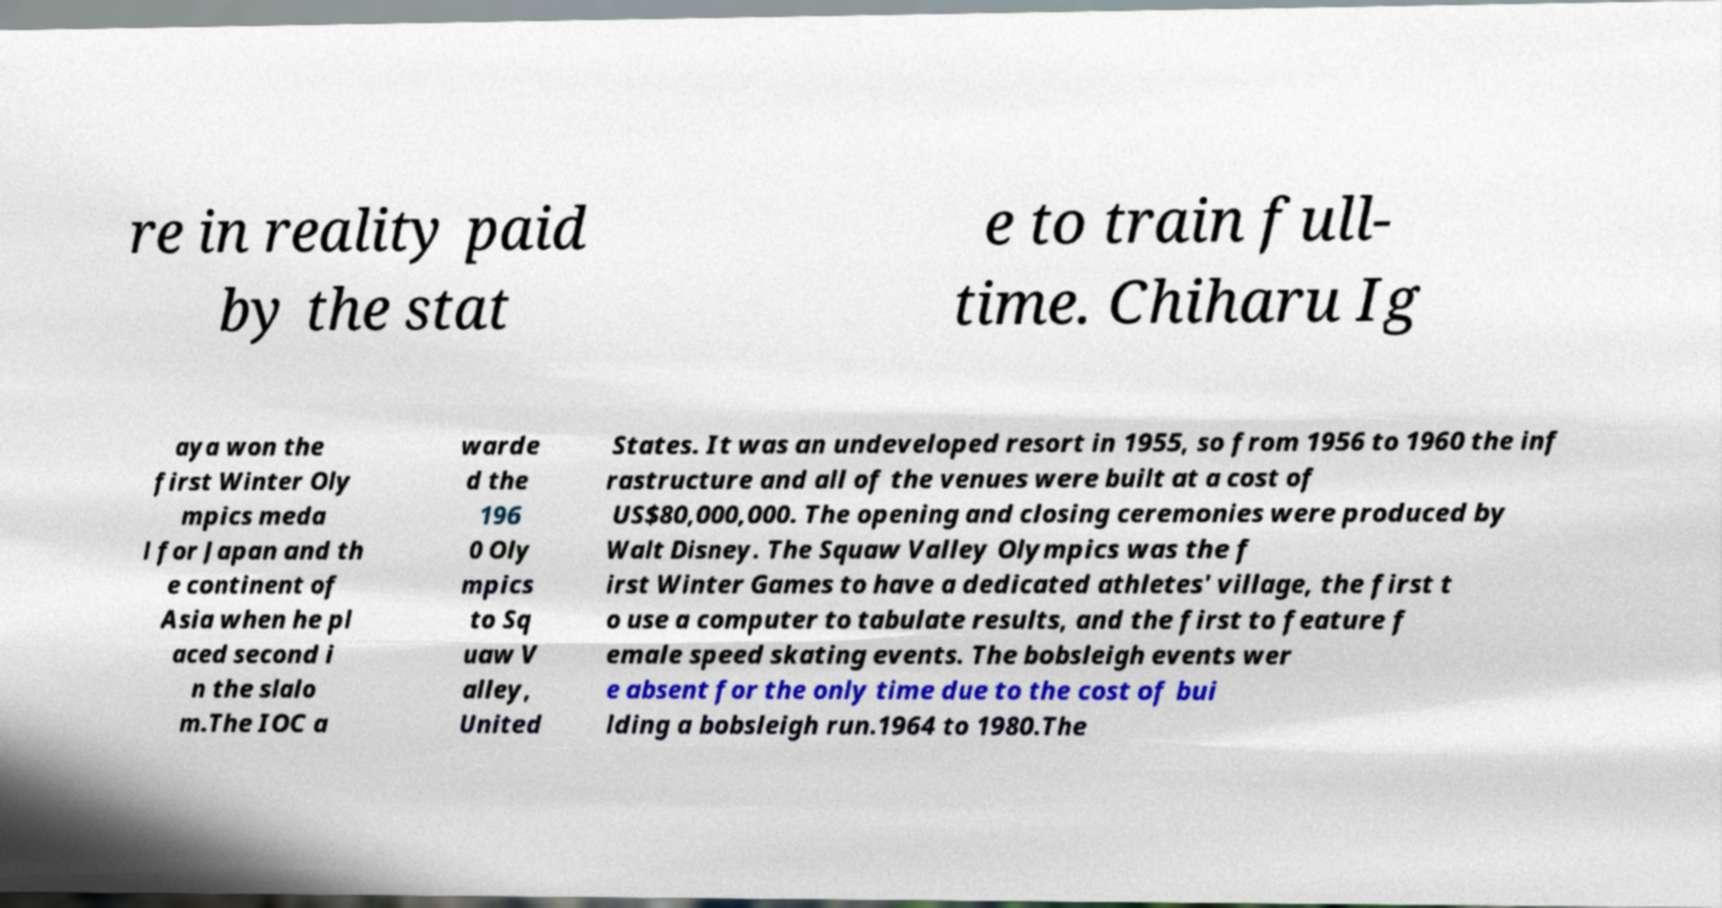I need the written content from this picture converted into text. Can you do that? re in reality paid by the stat e to train full- time. Chiharu Ig aya won the first Winter Oly mpics meda l for Japan and th e continent of Asia when he pl aced second i n the slalo m.The IOC a warde d the 196 0 Oly mpics to Sq uaw V alley, United States. It was an undeveloped resort in 1955, so from 1956 to 1960 the inf rastructure and all of the venues were built at a cost of US$80,000,000. The opening and closing ceremonies were produced by Walt Disney. The Squaw Valley Olympics was the f irst Winter Games to have a dedicated athletes' village, the first t o use a computer to tabulate results, and the first to feature f emale speed skating events. The bobsleigh events wer e absent for the only time due to the cost of bui lding a bobsleigh run.1964 to 1980.The 